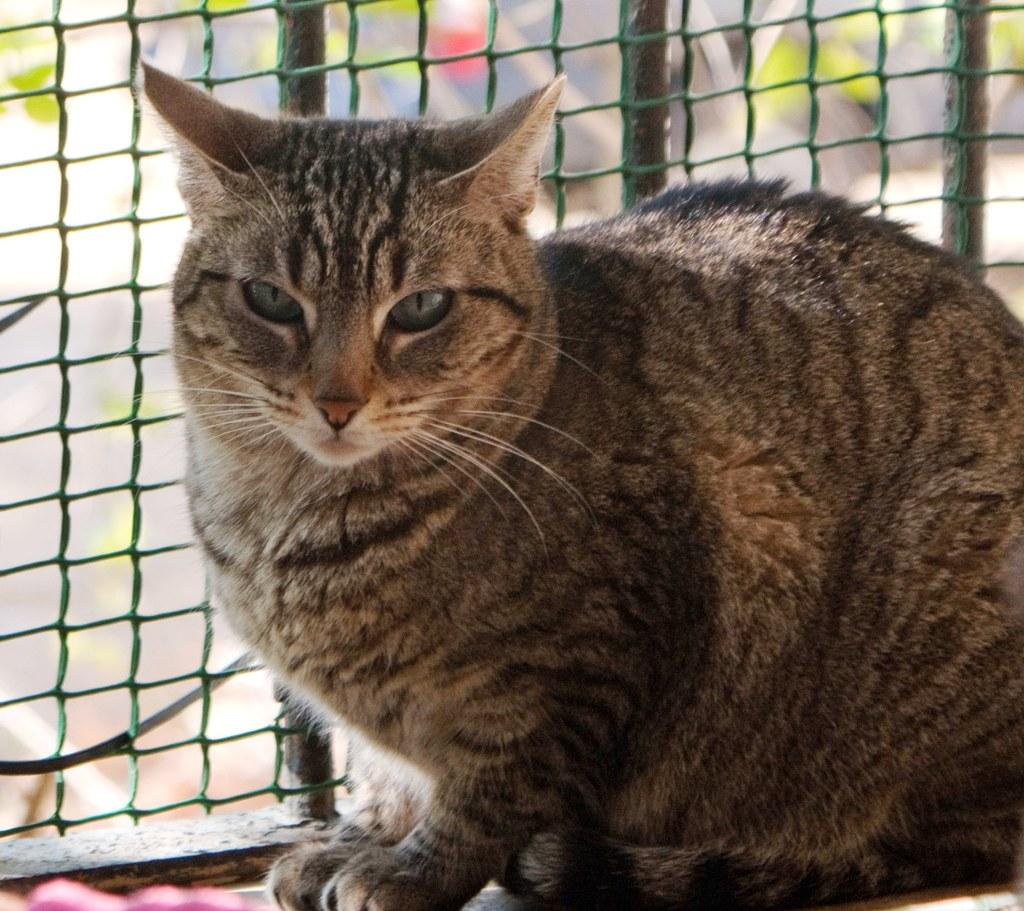What type of animal is in the image? There is a cat in the image. What is located behind the cat? There is fencing behind the cat. What type of note is the cat holding in the image? There is no note present in the image, as the cat is not holding anything. 